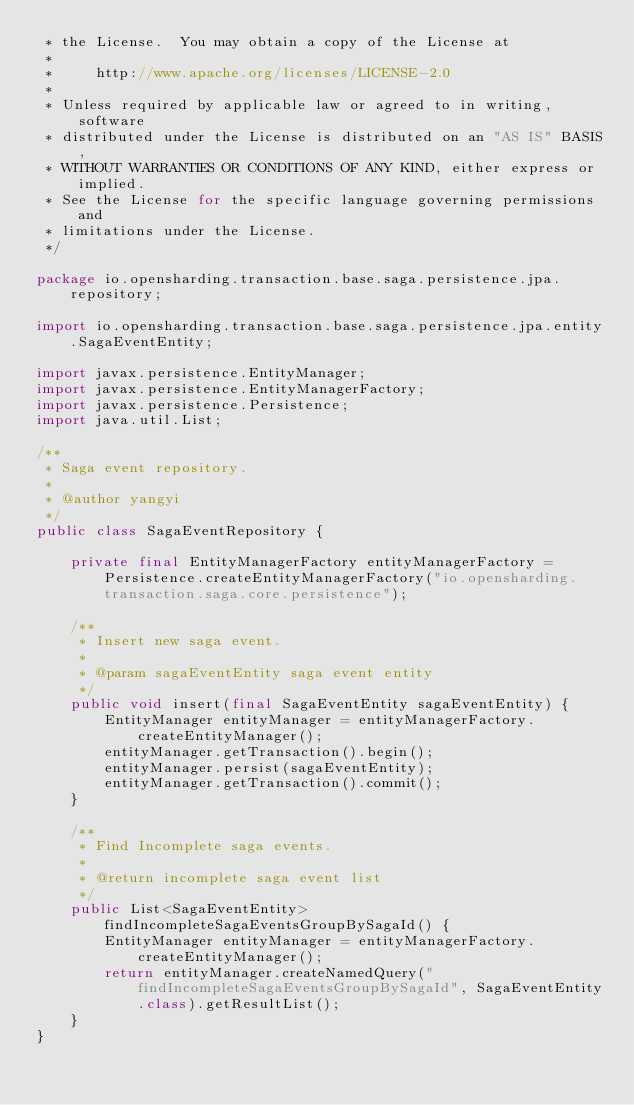Convert code to text. <code><loc_0><loc_0><loc_500><loc_500><_Java_> * the License.  You may obtain a copy of the License at
 *
 *     http://www.apache.org/licenses/LICENSE-2.0
 *
 * Unless required by applicable law or agreed to in writing, software
 * distributed under the License is distributed on an "AS IS" BASIS,
 * WITHOUT WARRANTIES OR CONDITIONS OF ANY KIND, either express or implied.
 * See the License for the specific language governing permissions and
 * limitations under the License.
 */

package io.opensharding.transaction.base.saga.persistence.jpa.repository;

import io.opensharding.transaction.base.saga.persistence.jpa.entity.SagaEventEntity;

import javax.persistence.EntityManager;
import javax.persistence.EntityManagerFactory;
import javax.persistence.Persistence;
import java.util.List;

/**
 * Saga event repository.
 *
 * @author yangyi
 */
public class SagaEventRepository {
    
    private final EntityManagerFactory entityManagerFactory = Persistence.createEntityManagerFactory("io.opensharding.transaction.saga.core.persistence");
    
    /**
     * Insert new saga event.
     *
     * @param sagaEventEntity saga event entity
     */
    public void insert(final SagaEventEntity sagaEventEntity) {
        EntityManager entityManager = entityManagerFactory.createEntityManager();
        entityManager.getTransaction().begin();
        entityManager.persist(sagaEventEntity);
        entityManager.getTransaction().commit();
    }
    
    /**
     * Find Incomplete saga events.
     *
     * @return incomplete saga event list
     */
    public List<SagaEventEntity> findIncompleteSagaEventsGroupBySagaId() {
        EntityManager entityManager = entityManagerFactory.createEntityManager();
        return entityManager.createNamedQuery("findIncompleteSagaEventsGroupBySagaId", SagaEventEntity.class).getResultList();
    }
}
</code> 